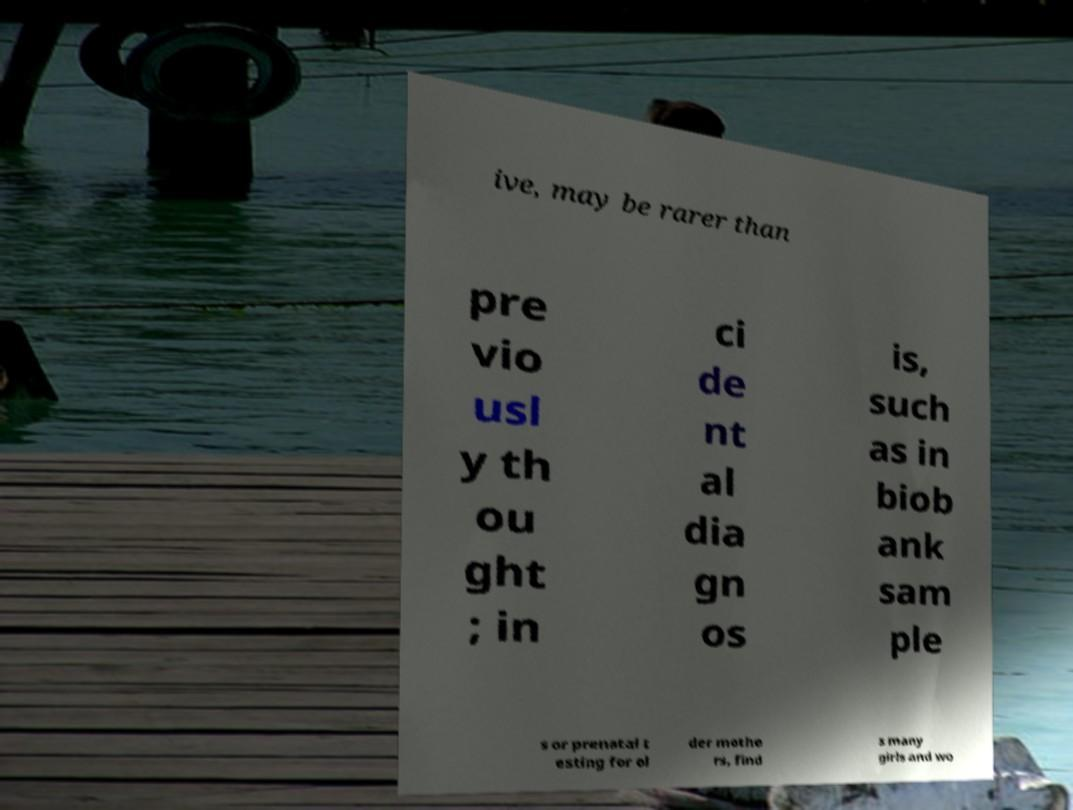Please read and relay the text visible in this image. What does it say? ive, may be rarer than pre vio usl y th ou ght ; in ci de nt al dia gn os is, such as in biob ank sam ple s or prenatal t esting for ol der mothe rs, find s many girls and wo 